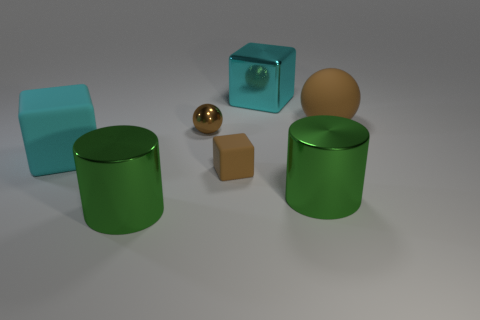Is there a cylinder that has the same color as the big matte cube?
Your answer should be compact. No. What color is the metallic ball that is the same size as the brown block?
Give a very brief answer. Brown. There is a large green shiny thing that is in front of the green cylinder to the right of the big metal block that is behind the small rubber cube; what shape is it?
Offer a terse response. Cylinder. There is a large block that is to the left of the brown rubber cube; how many small objects are behind it?
Give a very brief answer. 1. There is a big green metallic thing left of the big cyan shiny object; is it the same shape as the metal object right of the large cyan metallic thing?
Your answer should be very brief. Yes. There is a brown metallic ball; what number of cyan things are in front of it?
Your response must be concise. 1. Is the material of the cyan cube behind the cyan rubber block the same as the tiny brown sphere?
Your answer should be very brief. Yes. The small metallic object that is the same shape as the big brown thing is what color?
Ensure brevity in your answer.  Brown. What shape is the large cyan metal thing?
Make the answer very short. Cube. What number of objects are cylinders or big objects?
Keep it short and to the point. 5. 